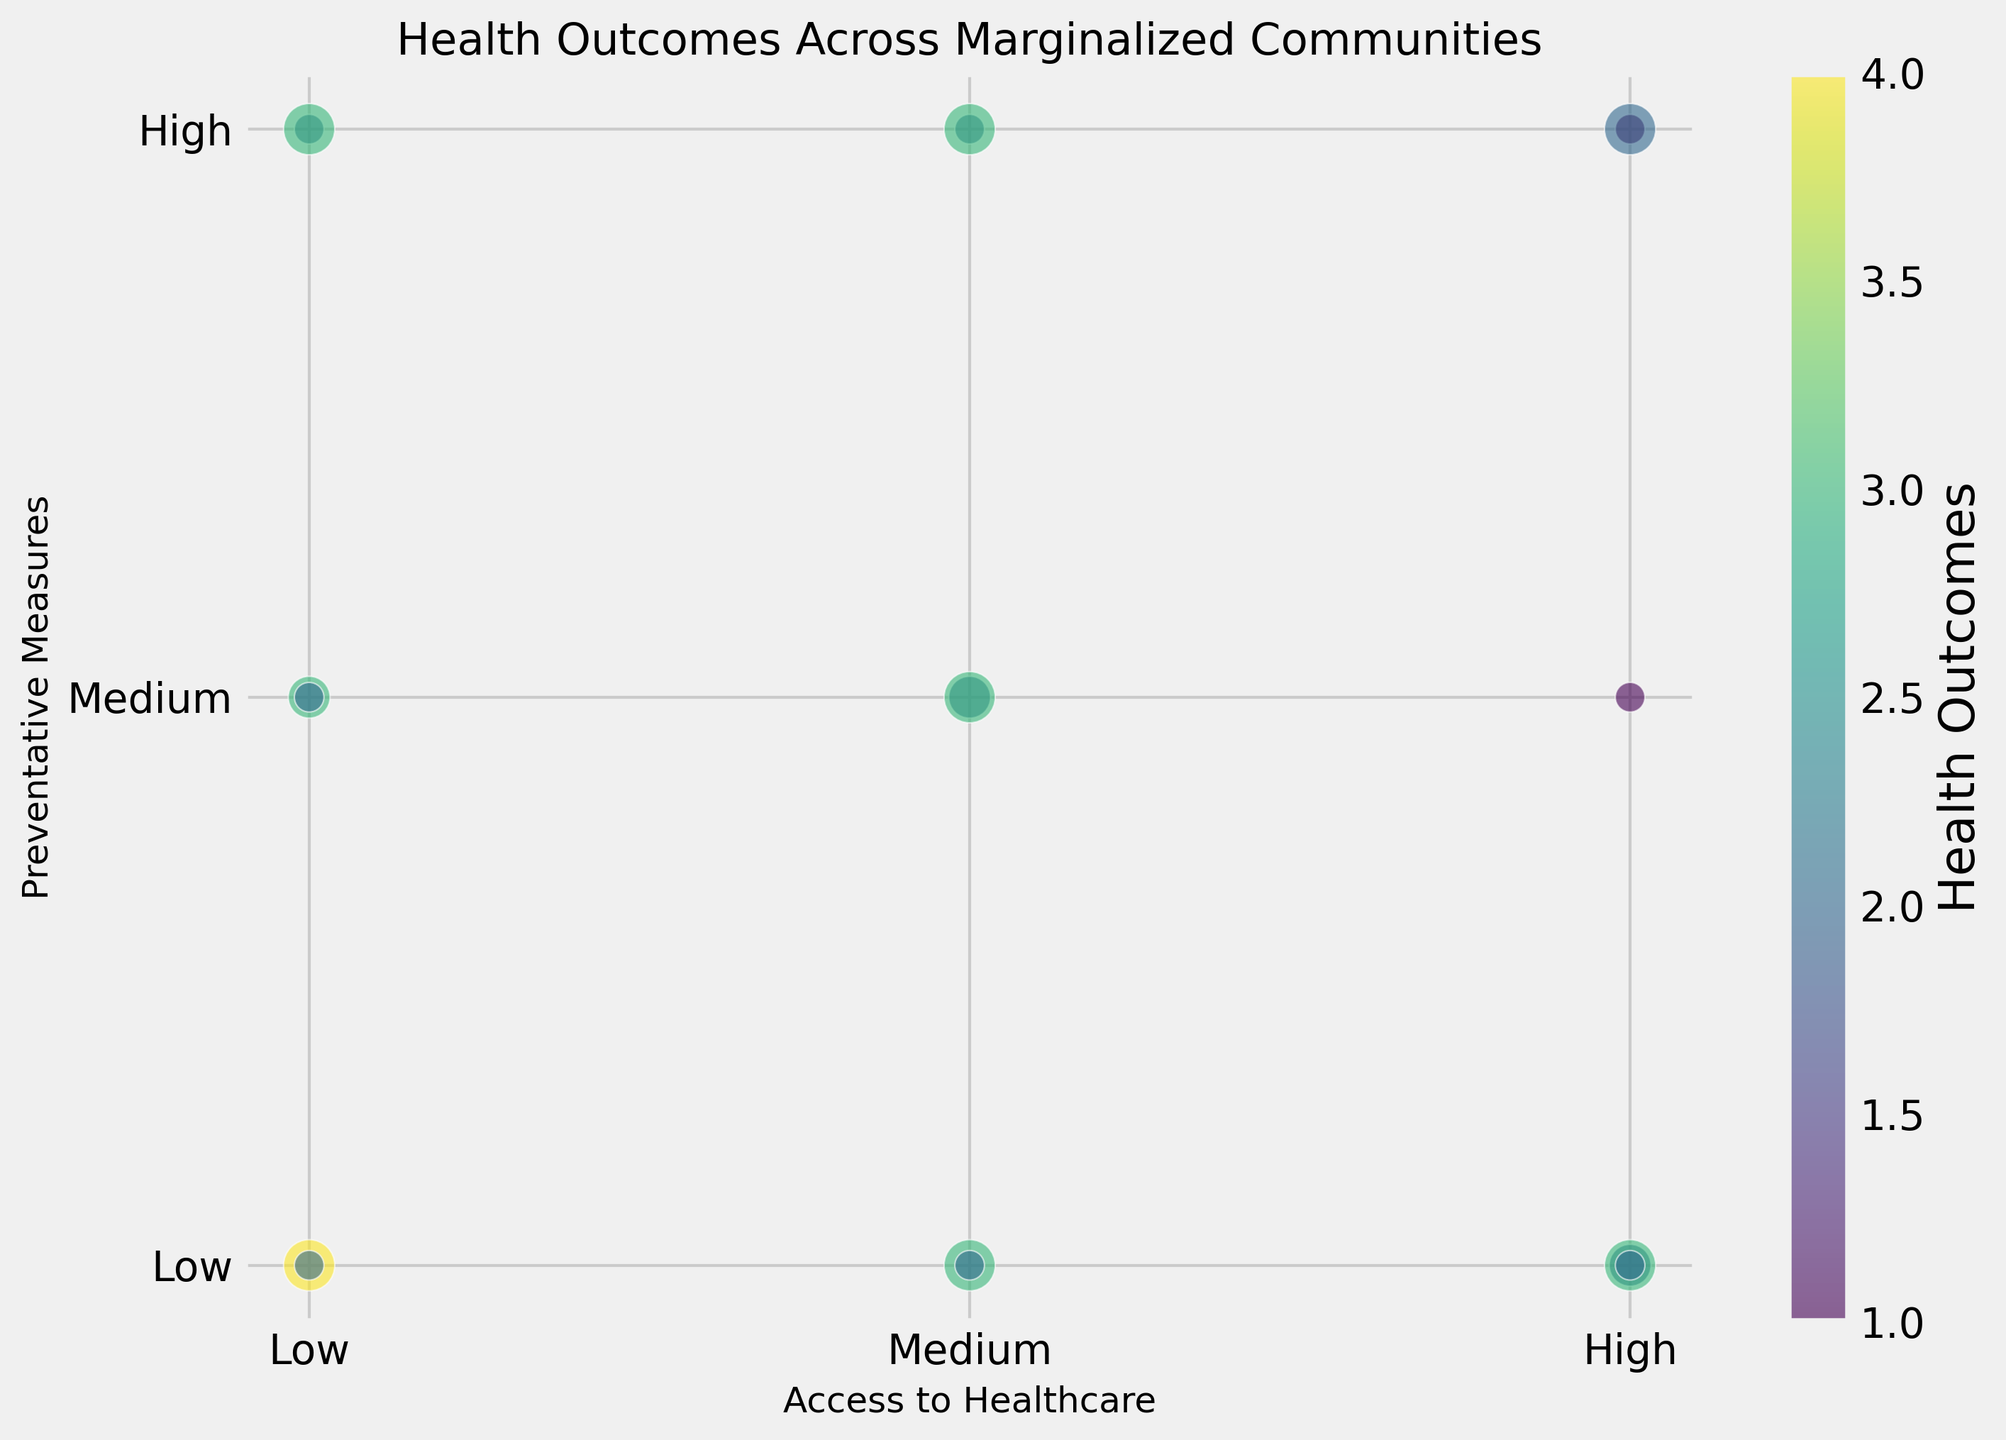Which access level to healthcare has the fewest chronic conditions but still leads to moderate health outcomes? Look for bubbles representing 'Few' chronic conditions and 'Moderate' health outcomes. Among these, identify the one with the smallest access level.
Answer: Low How does access to healthcare correlate with health outcomes for communities with high preventative measures? Identify the bubbles with 'High' preventative measures. Compare their access levels and respective health outcomes.
Answer: Higher access generally leads to better health outcomes Which combination of access to healthcare and preventative measures is associated with the poorest health outcomes? Look for the colors representing 'Poor' and 'Very Poor' outcomes. Note their positions that show combined access and preventative measures levels.
Answer: Low access and low preventative measures What's the difference in health outcomes between communities with high and low chronic conditions when both have medium access to healthcare? Identify bubbles with 'Medium' access and compare colors representing different levels of chronic conditions (Few, Moderate, Many). Note the corresponding health outcomes.
Answer: Few: Moderate; Many: Poor What is the prevailing preventative measure level for communities with 'Very Poor' health outcomes? Locate the darkest-colored bubble representing 'Very Poor' outcomes and observe its position on the y-axis (for preventative measures).
Answer: Low How much do health outcomes improve with high preventative measures versus low ones, keeping access to healthcare constant at high? Compare the colors of bubbles in the high access category between different y-axis levels (high vs low preventative measures).
Answer: Moderate to Poor improvement Which access to healthcare level has the most variance in health outcomes? Identify the access level with the widest range of colors (different health outcomes) in bubbles.
Answer: High What is the trend in health outcomes as chronic conditions increase while keeping preventative measures medium? Observe bubbles with 'Medium' preventative measures across different chronic condition sizes and note the color changes indicating health outcomes.
Answer: Moderate to Poor What is the average access to healthcare for communities with 'Few' chronic conditions and 'Moderate' preventive measures? Add all the numeric values for access in the bubbles representing 'Few' chronic conditions and 'Medium' preventative measures, then divide by the number of such bubbles.
Answer: 2 Is there any instance of 'Good' health outcomes with low access to healthcare? Review the bubbles to check for any light-colored (Good) bubbles in the 'Low' access area.
Answer: No 